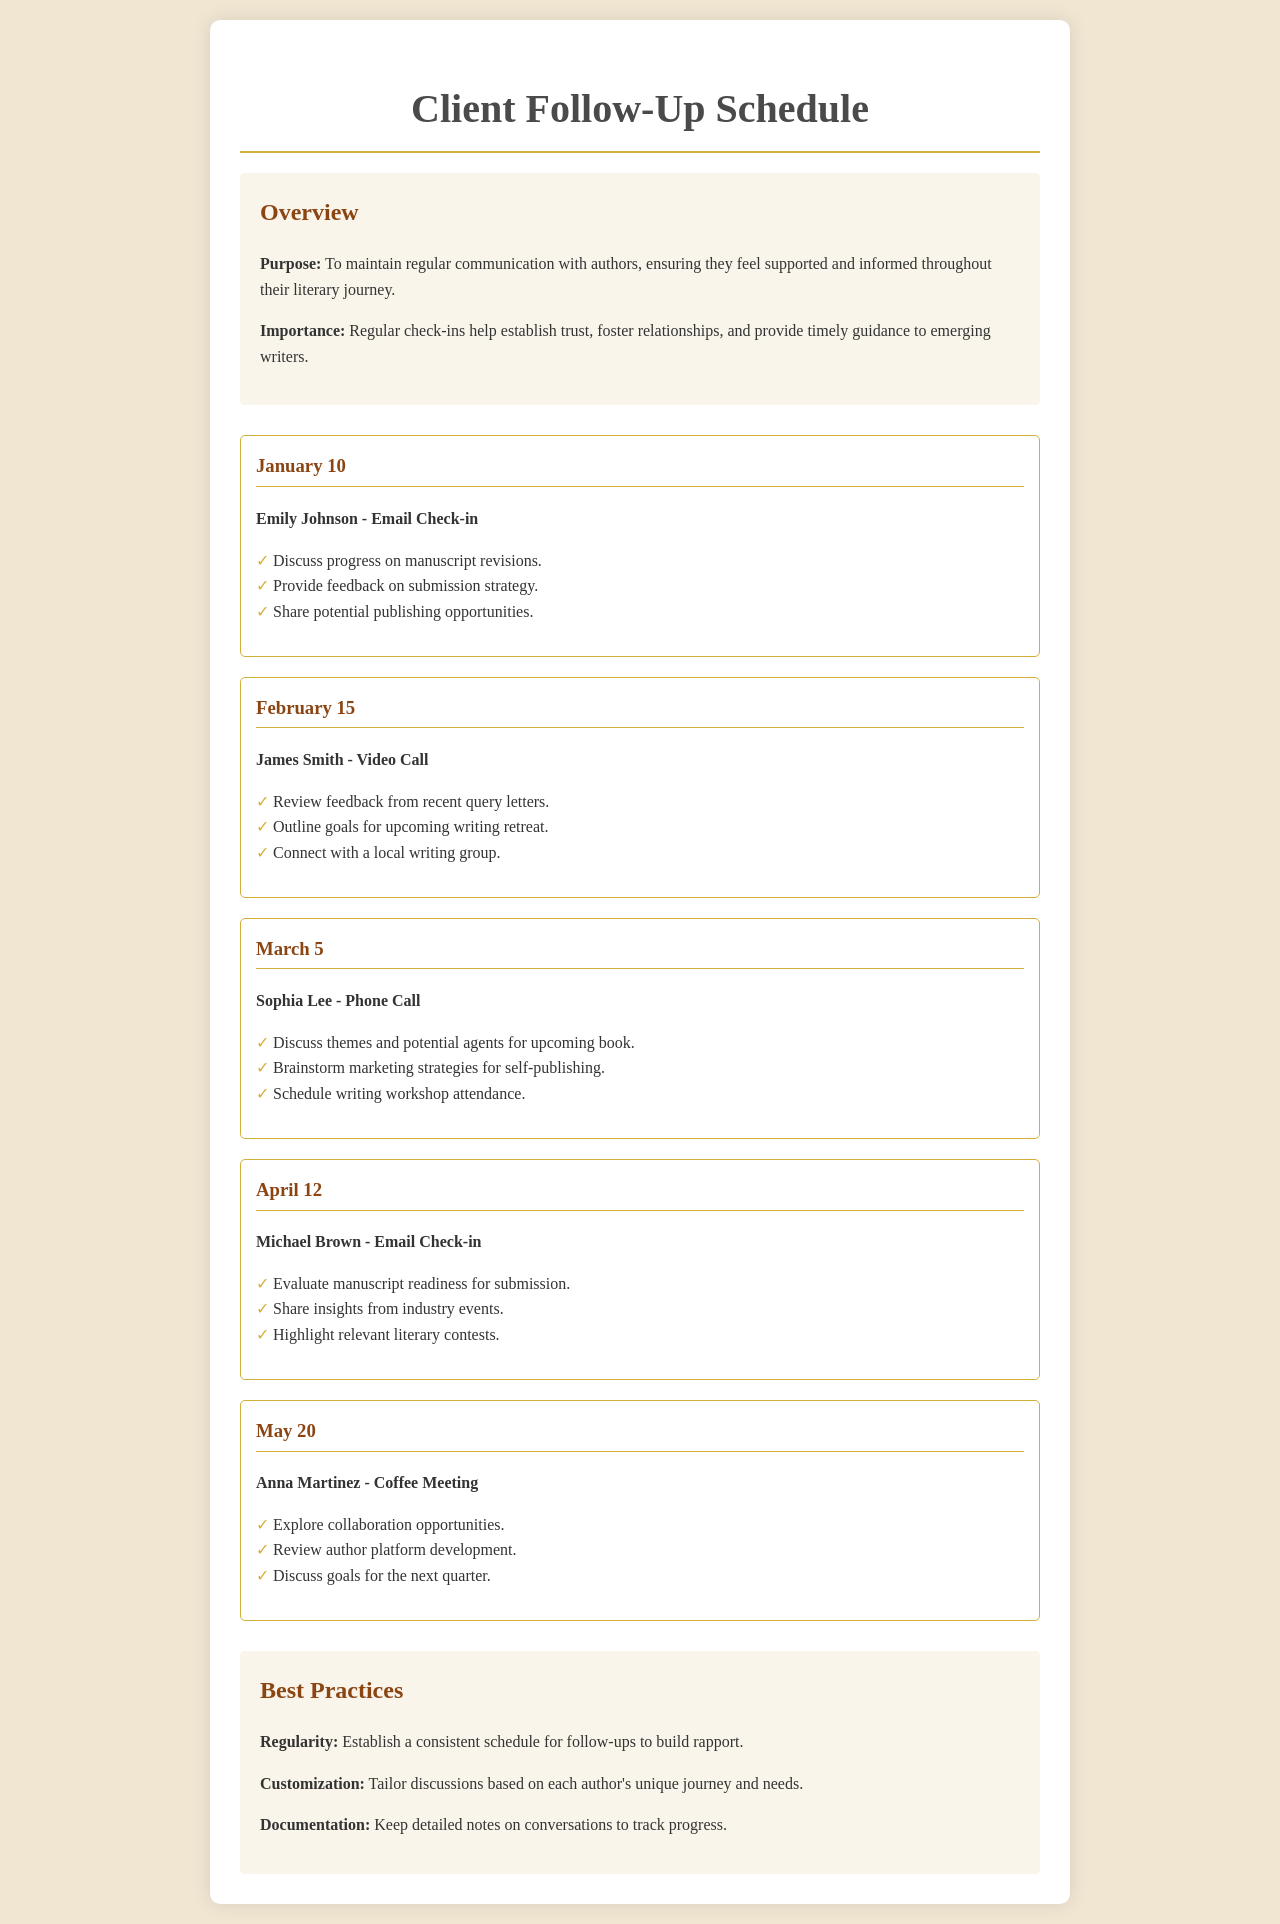What is the first author's name in the schedule? The first author mentioned in the schedule is Emily Johnson, listed under the January 10 entry.
Answer: Emily Johnson When is the next follow-up after March 5? The follow-up after March 5 is scheduled for April 12, according to the schedule.
Answer: April 12 What type of meeting is planned with Anna Martinez? The meeting type planned with Anna Martinez is a coffee meeting, as indicated in the May 20 entry.
Answer: Coffee Meeting How many action items are listed for James Smith? James Smith has three action items listed under the February 15 entry in the schedule.
Answer: 3 What is the purpose of the follow-up schedule? The purpose is to maintain regular communication with authors, ensuring they feel supported throughout their literary journey.
Answer: To maintain regular communication What month includes a discussion about marketing strategies? The month that includes a discussion about marketing strategies is March, during the check-in with Sophia Lee.
Answer: March How many authors are mentioned in the schedule? There are five authors mentioned throughout the schedule entries.
Answer: 5 What action item is associated with the April 12 follow-up? One action item associated with the April 12 follow-up is to evaluate manuscript readiness for submission.
Answer: Evaluate manuscript readiness for submission 